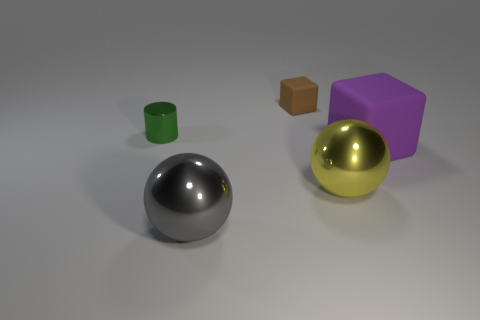What is the material of the large thing right of the yellow metal object that is in front of the cylinder?
Provide a succinct answer. Rubber. What is the block that is to the left of the big matte object made of?
Your answer should be very brief. Rubber. Does the large matte thing have the same shape as the small brown matte thing?
Offer a terse response. Yes. What number of big yellow things are the same shape as the tiny green object?
Your response must be concise. 0. There is a metallic cylinder to the left of the rubber thing on the left side of the large purple object; how big is it?
Ensure brevity in your answer.  Small. Does the purple thing have the same size as the yellow ball?
Your answer should be compact. Yes. There is a matte block that is to the left of the rubber block that is in front of the green metal object; is there a green object that is in front of it?
Make the answer very short. Yes. How big is the gray shiny sphere?
Make the answer very short. Large. What number of balls are the same size as the green thing?
Make the answer very short. 0. There is a large gray thing that is the same shape as the large yellow metallic object; what is its material?
Your answer should be very brief. Metal. 